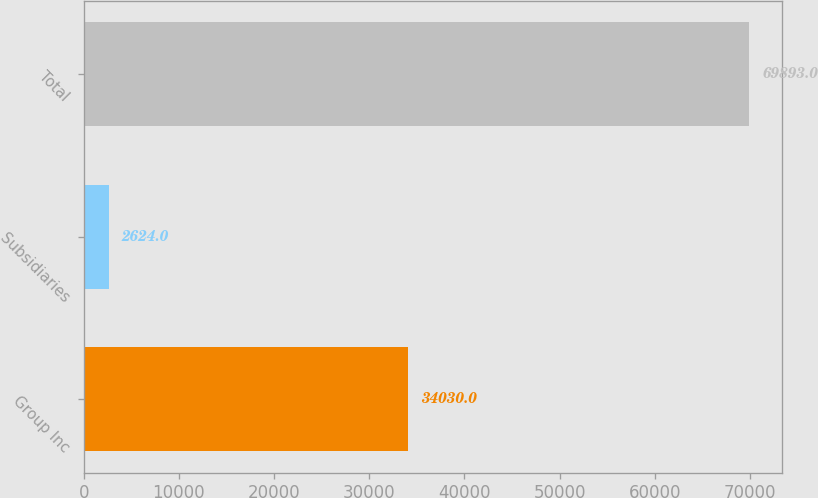Convert chart to OTSL. <chart><loc_0><loc_0><loc_500><loc_500><bar_chart><fcel>Group Inc<fcel>Subsidiaries<fcel>Total<nl><fcel>34030<fcel>2624<fcel>69893<nl></chart> 